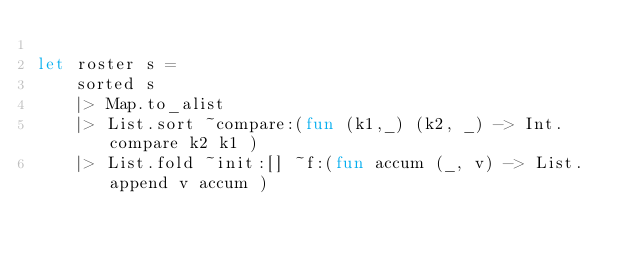Convert code to text. <code><loc_0><loc_0><loc_500><loc_500><_OCaml_>    
let roster s =
    sorted s
    |> Map.to_alist
    |> List.sort ~compare:(fun (k1,_) (k2, _) -> Int.compare k2 k1 )
    |> List.fold ~init:[] ~f:(fun accum (_, v) -> List.append v accum )
</code> 